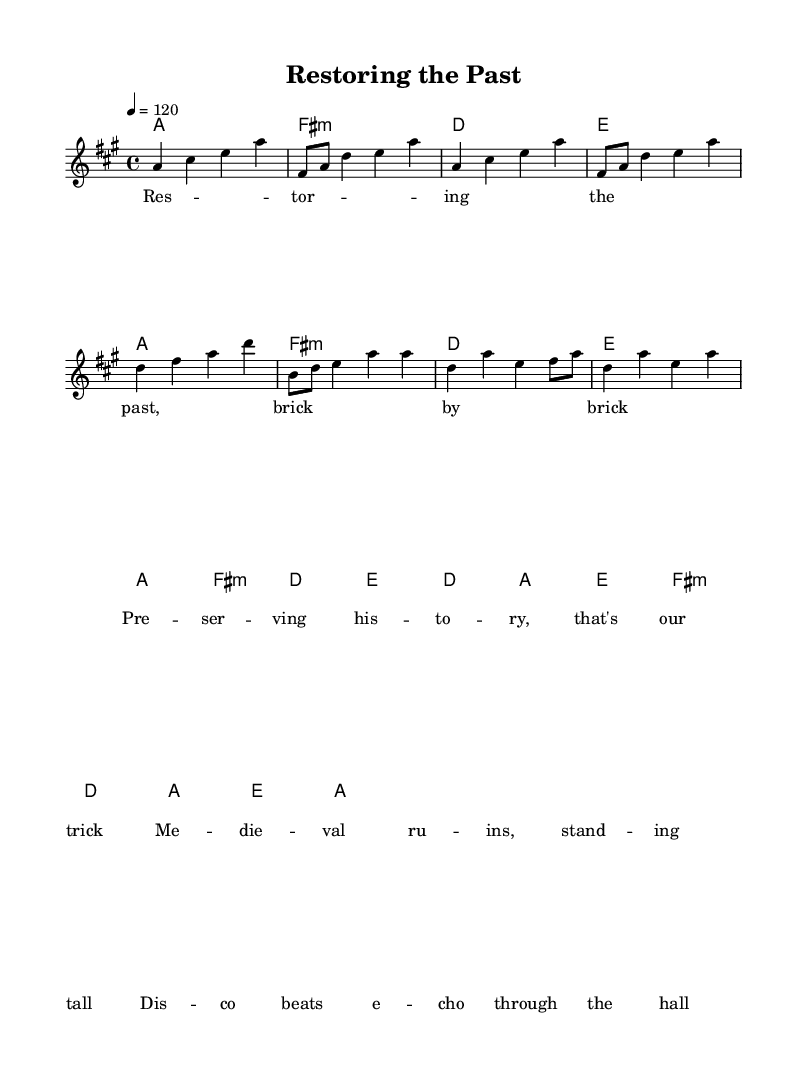What is the key signature of this music? The key signature is A major, which has three sharps: F sharp, C sharp, and G sharp. This is indicated by the key signature at the beginning of the staff.
Answer: A major What is the time signature of the piece? The time signature is 4/4, meaning there are four beats in a measure and the quarter note gets one beat. This is shown at the beginning of the music.
Answer: 4/4 What is the tempo of the music? The tempo is set at 120 beats per minute, which indicates a moderately fast pace. The tempo marking is placed at the beginning of the score.
Answer: 120 How many measures are there in the chorus section? The chorus section consists of three measures, which can be counted by visually identifying the divisions within the music. Each measure typically has a bar line at the end.
Answer: 3 What type of chords are predominantly used in the chorus? The predominant chords are major chords, as observed in the chord progression during the chorus: D major, A major, E major, and F sharp minor, where most are labeled as major.
Answer: Major What rhythmic feel does the melody create in the verse? The melody creates an upbeat rhythmic feel with syncopation and a lively stepwise motion, emphasizing energy typical of disco music. This can be assessed by analyzing note placements and note durations.
Answer: Upbeat What historical theme is celebrated in this disco tune? The theme celebrated in this disco tune is the preservation and restoration of historical sites, particularly medieval ruins, as indicated by the lyrics and overall concept of the piece.
Answer: Historical preservation 